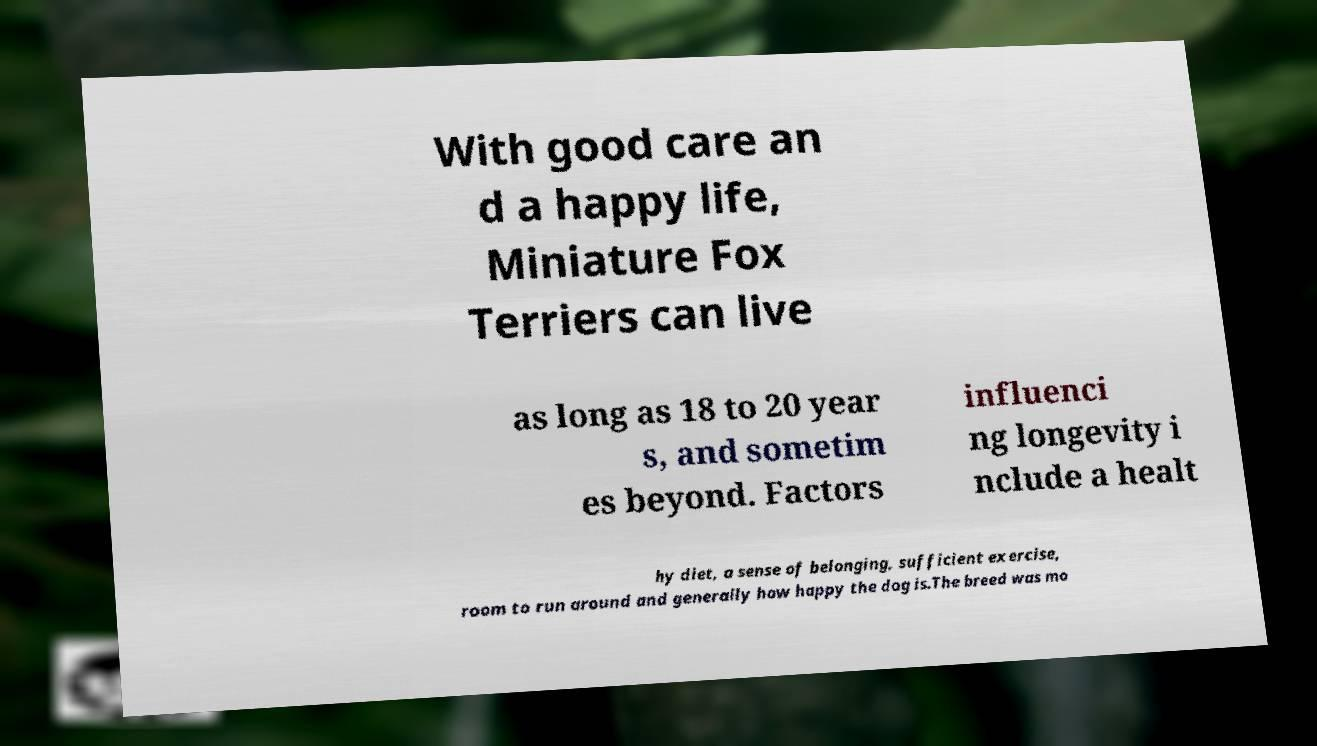Can you accurately transcribe the text from the provided image for me? With good care an d a happy life, Miniature Fox Terriers can live as long as 18 to 20 year s, and sometim es beyond. Factors influenci ng longevity i nclude a healt hy diet, a sense of belonging, sufficient exercise, room to run around and generally how happy the dog is.The breed was mo 